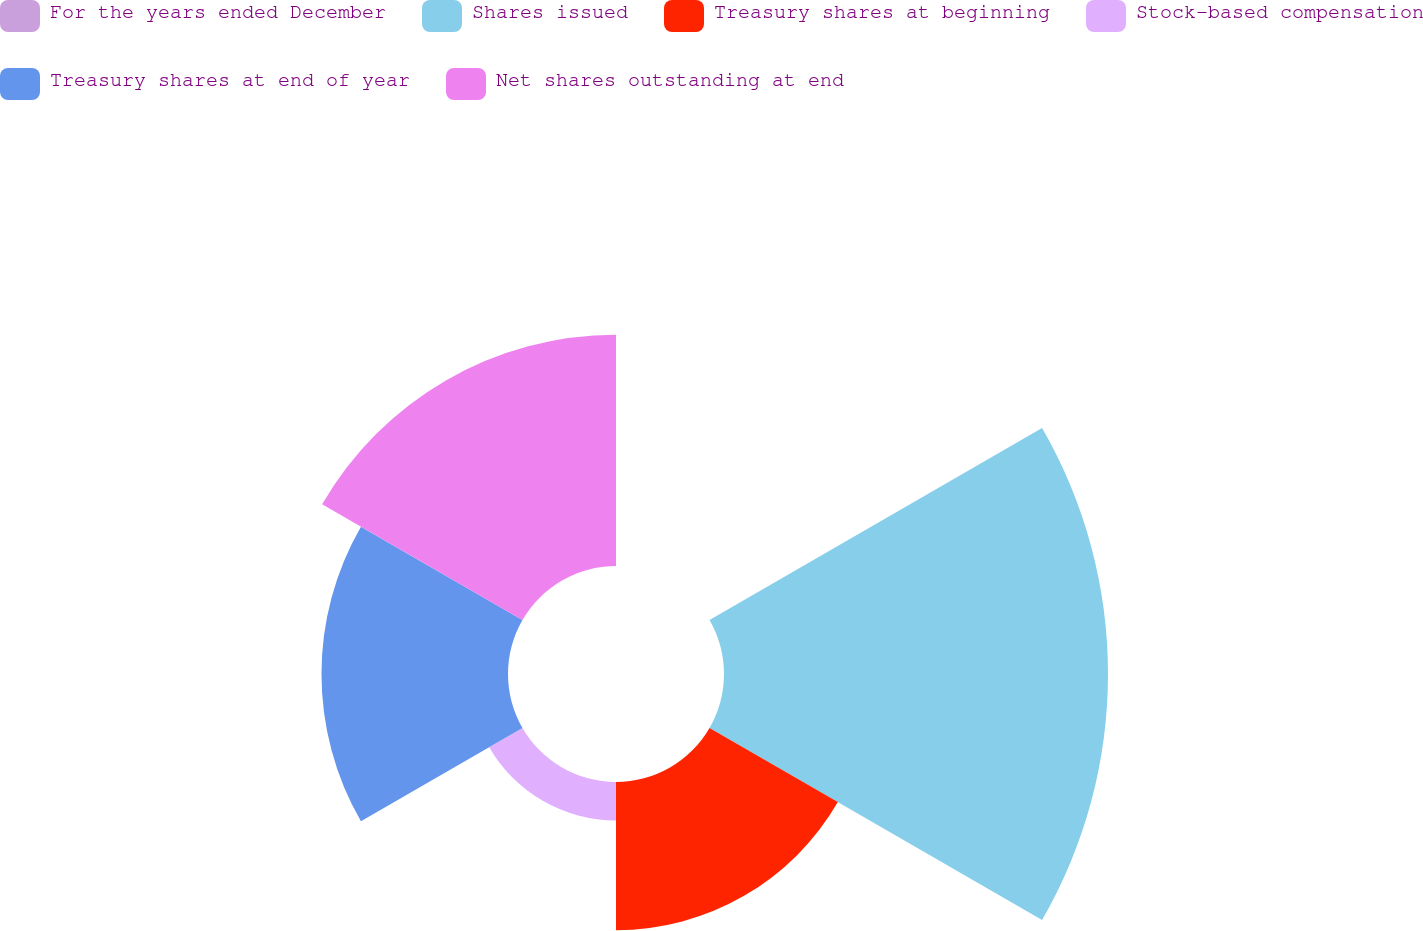<chart> <loc_0><loc_0><loc_500><loc_500><pie_chart><fcel>For the years ended December<fcel>Shares issued<fcel>Treasury shares at beginning<fcel>Stock-based compensation<fcel>Treasury shares at end of year<fcel>Net shares outstanding at end<nl><fcel>0.0%<fcel>38.85%<fcel>14.99%<fcel>3.89%<fcel>18.87%<fcel>23.4%<nl></chart> 